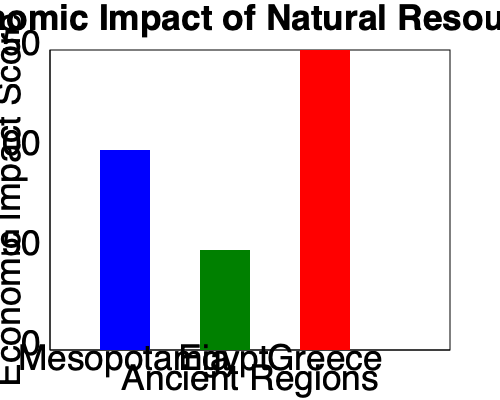Based on the bar chart comparing the economic impact of natural resources in ancient Mesopotamia, Egypt, and Greece, which region appears to have had the strongest land-based economy, and how might this have influenced its economic development compared to regions with more maritime focus? To answer this question, we need to analyze the bar chart and consider the implications of natural resources on land-based economies:

1. Examine the bar heights:
   - Mesopotamia: approximately 100 units
   - Egypt: approximately 50 units
   - Greece: approximately 150 units

2. Identify the region with the highest score:
   Greece has the tallest bar, indicating the strongest economic impact from natural resources.

3. Consider the geographical characteristics of Greece:
   - Mountainous terrain with limited arable land
   - Extensive coastline and numerous islands

4. Analyze the implications for a land-based economy:
   - Despite having the highest score, Greece's geography is not ideal for a purely land-based economy
   - The high score likely reflects a combination of land and maritime resources

5. Compare with Mesopotamia:
   - Second-highest score
   - Located in the fertile crescent with extensive river systems
   - Better suited for a land-based agricultural economy

6. Evaluate Egypt:
   - Lowest score among the three
   - Nile River valley provided consistent agricultural output
   - Limited natural resources beyond the Nile Valley

7. Conclude on the strongest land-based economy:
   Mesopotamia, with its high score and favorable geography for agriculture, likely had the strongest land-based economy.

8. Consider the influence on economic development:
   - Mesopotamia's focus on land-based resources led to early urbanization and complex social structures
   - This contrasts with maritime-focused economies, which might have developed different trade patterns and social organizations
Answer: Mesopotamia had the strongest land-based economy, leading to early urbanization and complex social structures distinct from maritime-focused regions. 